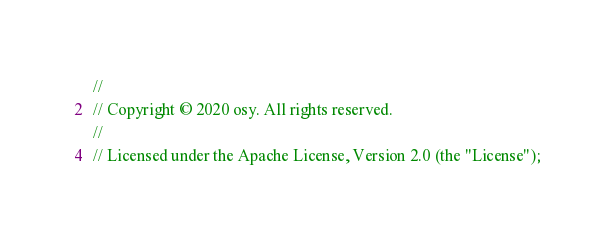<code> <loc_0><loc_0><loc_500><loc_500><_Swift_>//
// Copyright © 2020 osy. All rights reserved.
//
// Licensed under the Apache License, Version 2.0 (the "License");</code> 